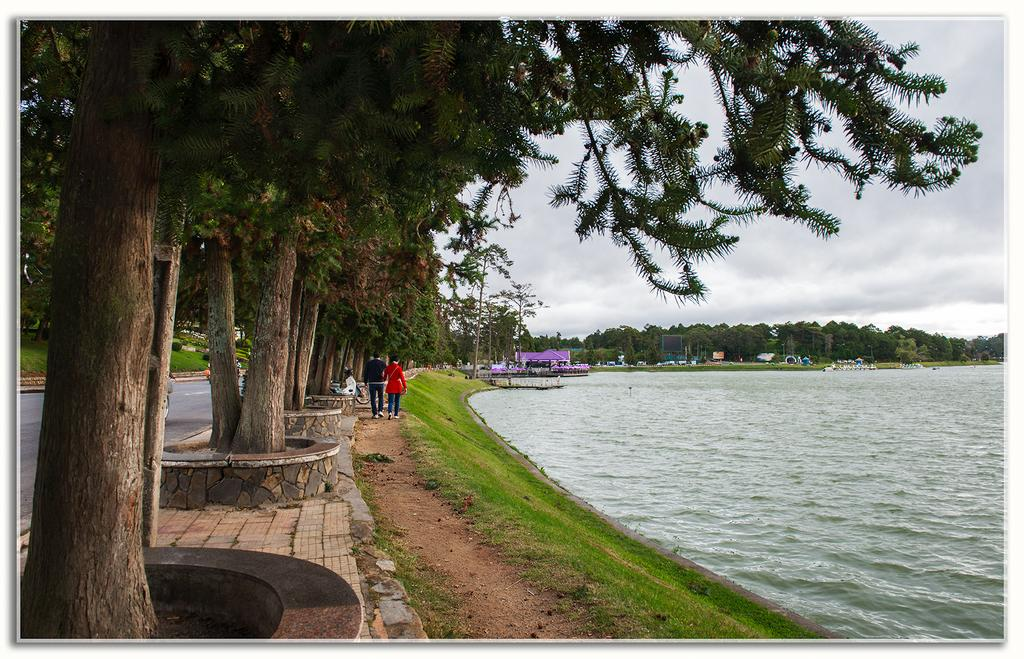How many people can be seen in the image? There are people in the image, but the exact number is not specified. What type of natural elements are present in the image? There are trees, plants, water, ground, grass, and sky visible in the image. What type of structures can be seen in the image? There are houses and poles visible in the image. What is the condition of the sky in the image? The sky is visible in the image, and there are clouds present. Can you tell me how many owls are sitting on the poles in the image? There are no owls present in the image; only people, trees, plants, water, ground, grass, houses, poles, and sky are visible. Is there any snow visible in the image? There is no snow present in the image; the ground and other elements are not covered in snow. 